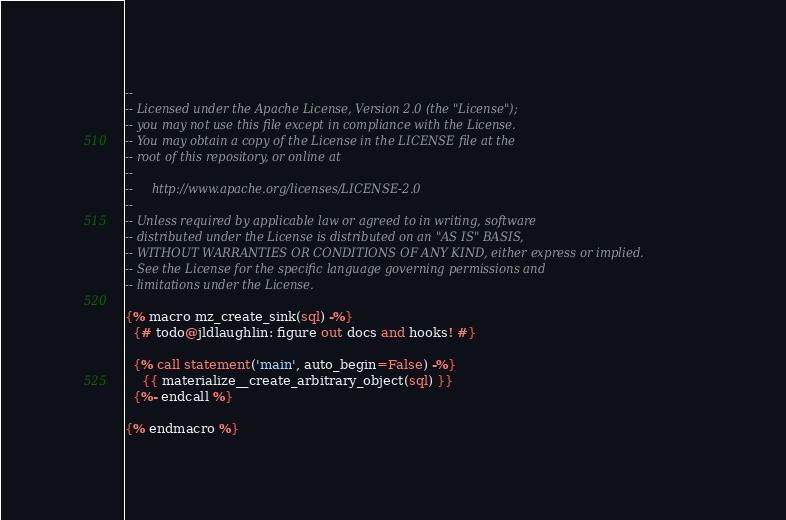<code> <loc_0><loc_0><loc_500><loc_500><_SQL_>--
-- Licensed under the Apache License, Version 2.0 (the "License");
-- you may not use this file except in compliance with the License.
-- You may obtain a copy of the License in the LICENSE file at the
-- root of this repository, or online at
--
--     http://www.apache.org/licenses/LICENSE-2.0
--
-- Unless required by applicable law or agreed to in writing, software
-- distributed under the License is distributed on an "AS IS" BASIS,
-- WITHOUT WARRANTIES OR CONDITIONS OF ANY KIND, either express or implied.
-- See the License for the specific language governing permissions and
-- limitations under the License.

{% macro mz_create_sink(sql) -%}
  {# todo@jldlaughlin: figure out docs and hooks! #}

  {% call statement('main', auto_begin=False) -%}
    {{ materialize__create_arbitrary_object(sql) }}
  {%- endcall %}

{% endmacro %}
</code> 